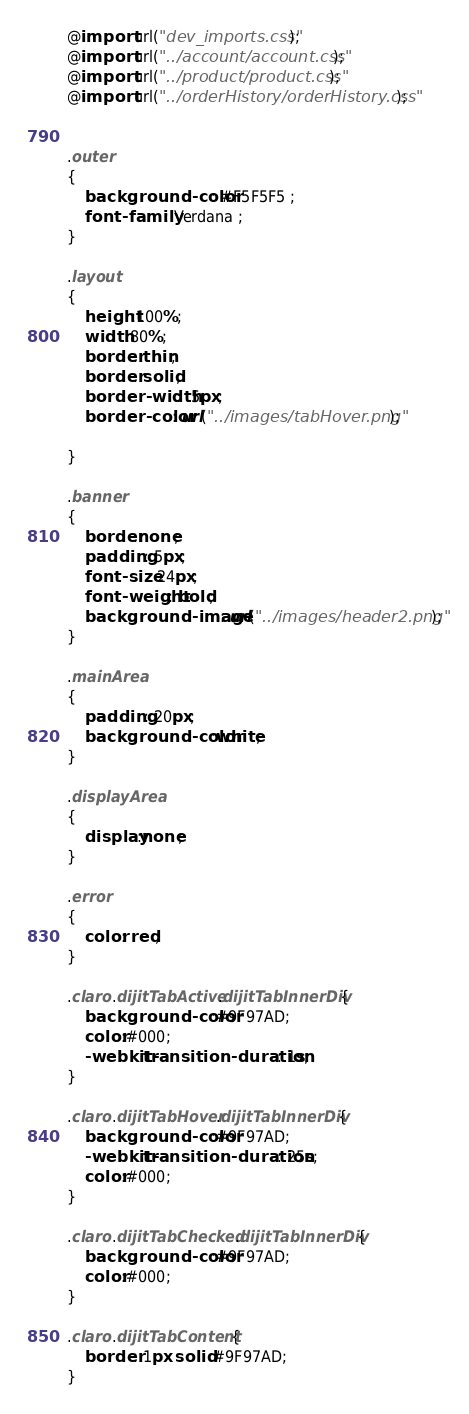Convert code to text. <code><loc_0><loc_0><loc_500><loc_500><_CSS_>@import url("dev_imports.css");
@import url("../account/account.css");
@import url("../product/product.css"); 
@import url("../orderHistory/orderHistory.css"); 


.outer
{
	background-color: #F5F5F5 ;
	font-family: Verdana ;
}

.layout
{
	height:100%;
	width:80%;
	border: thin;
	border: solid;
	border-width: .5px;
	border-color: url("../images/tabHover.png"); 
	
}

.banner
{
    border:none;
    padding: 5px;
    font-size: 24px;
    font-weight: bold;
    background-image: url("../images/header2.png");
}

.mainArea
{
	padding: 20px;
	background-color:white;
}

.displayArea
{
	display:none;
}

.error
{
	color: red;
}

.claro .dijitTabActive .dijitTabInnerDiv {
	background-color:#9F97AD;
	color:#000;
	-webkit-transition-duration:.1s;
}

.claro .dijitTabHover .dijitTabInnerDiv {
	background-color:#9F97AD;
 	-webkit-transition-duration:.25s;
	color:#000;
}

.claro .dijitTabChecked .dijitTabInnerDiv {
	background-color:#9F97AD;
	color:#000;
}

.claro .dijitTabContent {
	border: 1px solid #9F97AD;
}
</code> 